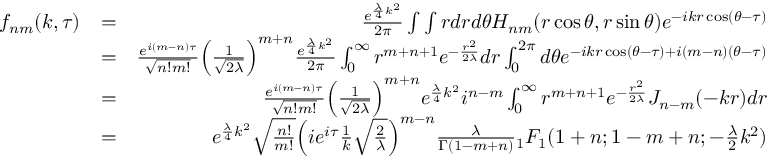Convert formula to latex. <formula><loc_0><loc_0><loc_500><loc_500>\begin{array} { r l r } { f _ { n m } ( k , \tau ) } & { = } & { \frac { e ^ { \frac { \lambda } { 4 } k ^ { 2 } } } { 2 \pi } \int \int r d r d \theta H _ { n m } ( r \cos \theta , r \sin \theta ) e ^ { - i k r \cos ( \theta - \tau ) } } \\ & { = } & { \frac { e ^ { i ( m - n ) \tau } } { \sqrt { n ! m ! } } \left ( \frac { 1 } { \sqrt { 2 \lambda } } \right ) ^ { m + n } \frac { e ^ { \frac { \lambda } { 4 } k ^ { 2 } } } { 2 \pi } \int _ { 0 } ^ { \infty } r ^ { m + n + 1 } e ^ { - \frac { r ^ { 2 } } { 2 \lambda } } d r \int _ { 0 } ^ { 2 \pi } d \theta e ^ { - i k r \cos ( \theta - \tau ) + i ( m - n ) ( \theta - \tau ) } } \\ & { = } & { \frac { e ^ { i ( m - n ) \tau } } { \sqrt { n ! m ! } } \left ( \frac { 1 } { \sqrt { 2 \lambda } } \right ) ^ { m + n } e ^ { \frac { \lambda } { 4 } k ^ { 2 } } i ^ { n - m } \int _ { 0 } ^ { \infty } r ^ { m + n + 1 } e ^ { - \frac { r ^ { 2 } } { 2 \lambda } } J _ { n - m } ( - k r ) d r } \\ & { = } & { e ^ { \frac { \lambda } { 4 } k ^ { 2 } } \sqrt { \frac { n ! } { m ! } } \left ( i e ^ { i \tau } \frac { 1 } { k } \sqrt { \frac { 2 } { \lambda } } \right ) ^ { m - n } \frac { \lambda } { \Gamma ( 1 - m + n ) } { _ { 1 } F _ { 1 } } ( 1 + n ; 1 - m + n ; - \frac { \lambda } { 2 } k ^ { 2 } ) } \end{array}</formula> 